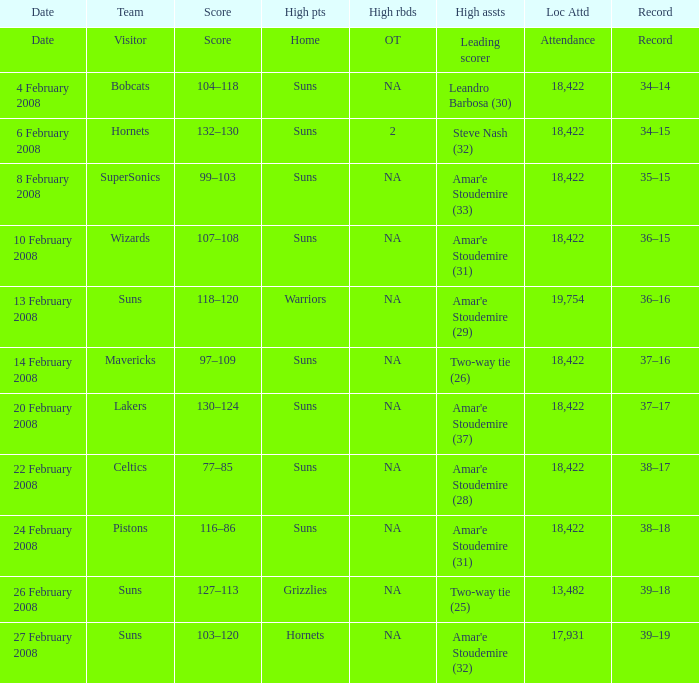How many high assists did the Lakers have? Amar'e Stoudemire (37). 